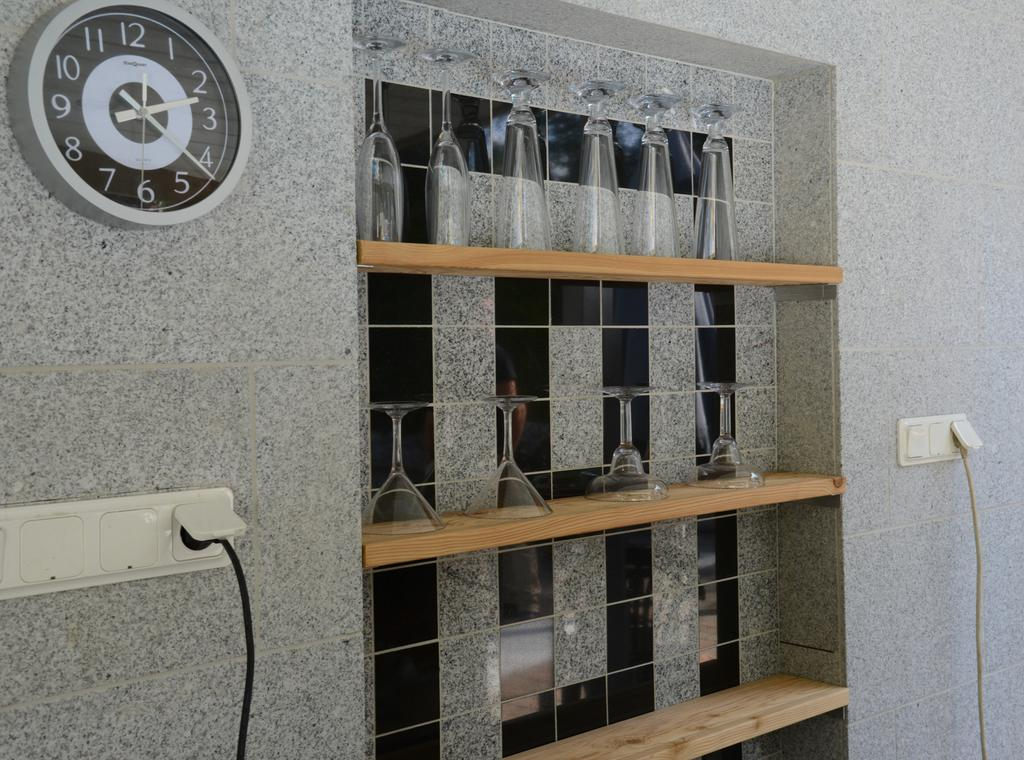<image>
Give a short and clear explanation of the subsequent image. A clock displaying the numbers 1 through 12 next to a shelf full of glasses. 